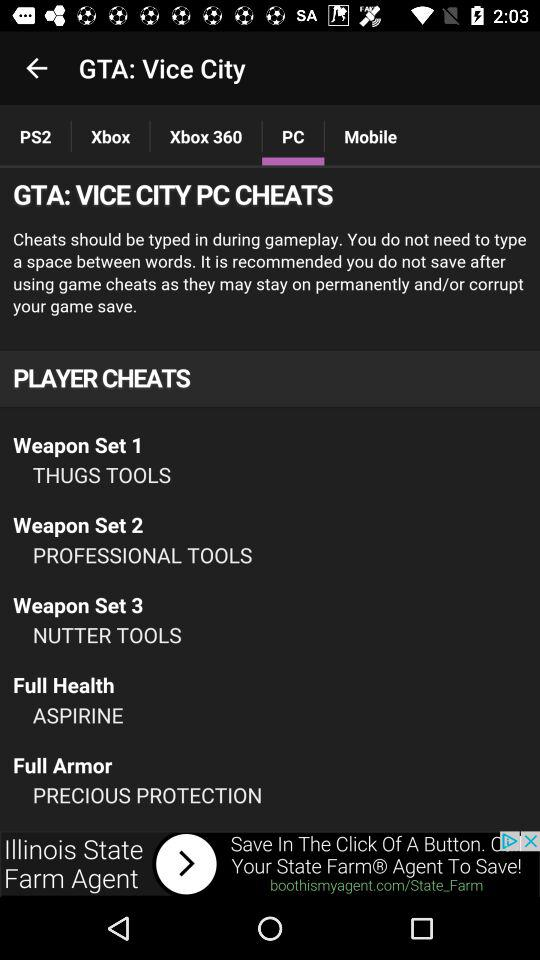Which tab has been selected? The selected tab is "PC". 